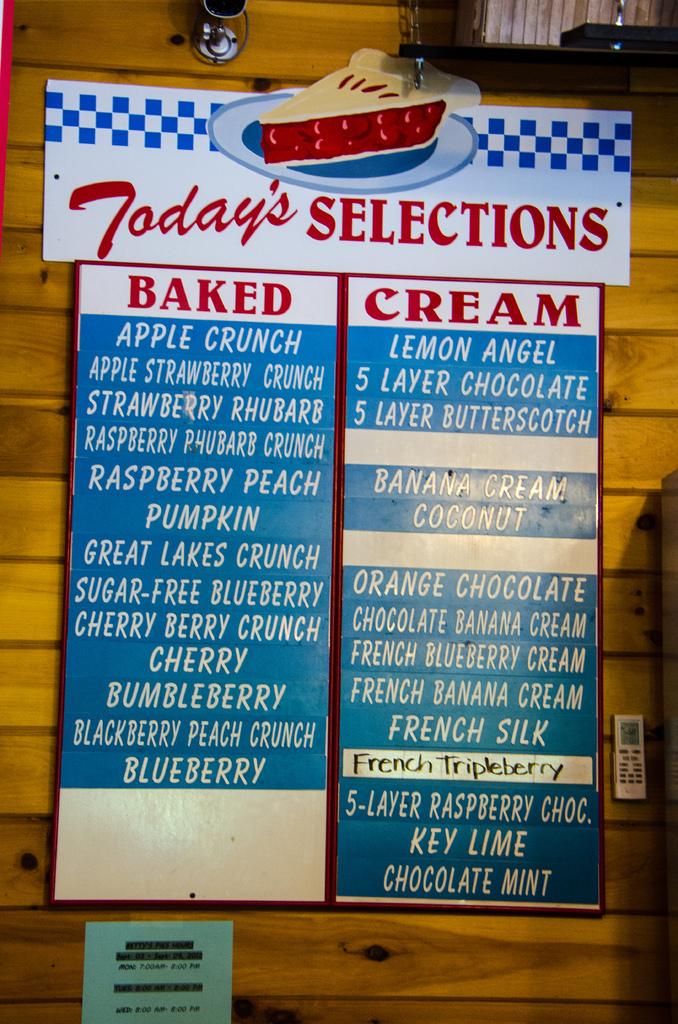Do they have baked goods?
Your answer should be compact. Yes. 